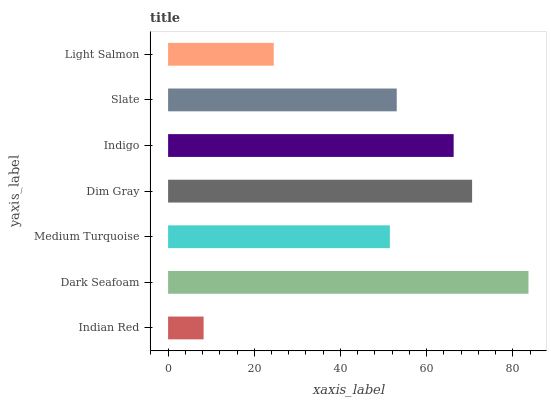Is Indian Red the minimum?
Answer yes or no. Yes. Is Dark Seafoam the maximum?
Answer yes or no. Yes. Is Medium Turquoise the minimum?
Answer yes or no. No. Is Medium Turquoise the maximum?
Answer yes or no. No. Is Dark Seafoam greater than Medium Turquoise?
Answer yes or no. Yes. Is Medium Turquoise less than Dark Seafoam?
Answer yes or no. Yes. Is Medium Turquoise greater than Dark Seafoam?
Answer yes or no. No. Is Dark Seafoam less than Medium Turquoise?
Answer yes or no. No. Is Slate the high median?
Answer yes or no. Yes. Is Slate the low median?
Answer yes or no. Yes. Is Dark Seafoam the high median?
Answer yes or no. No. Is Light Salmon the low median?
Answer yes or no. No. 